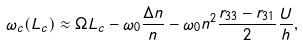<formula> <loc_0><loc_0><loc_500><loc_500>\omega _ { c } ( L _ { c } ) \approx \Omega L _ { c } - \omega _ { 0 } \frac { \Delta n } { n } - \omega _ { 0 } n ^ { 2 } \frac { r _ { 3 3 } - r _ { 3 1 } } { 2 } \frac { U } { h } ,</formula> 